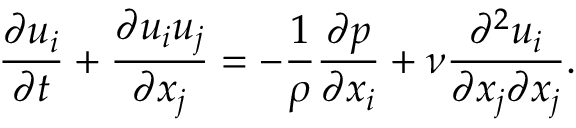<formula> <loc_0><loc_0><loc_500><loc_500>{ \frac { \partial u _ { i } } { \partial t } } + { \frac { \partial u _ { i } u _ { j } } { \partial x _ { j } } } = - { \frac { 1 } { \rho } } { \frac { \partial p } { \partial x _ { i } } } + \nu { \frac { \partial ^ { 2 } u _ { i } } { \partial x _ { j } \partial x _ { j } } } .</formula> 